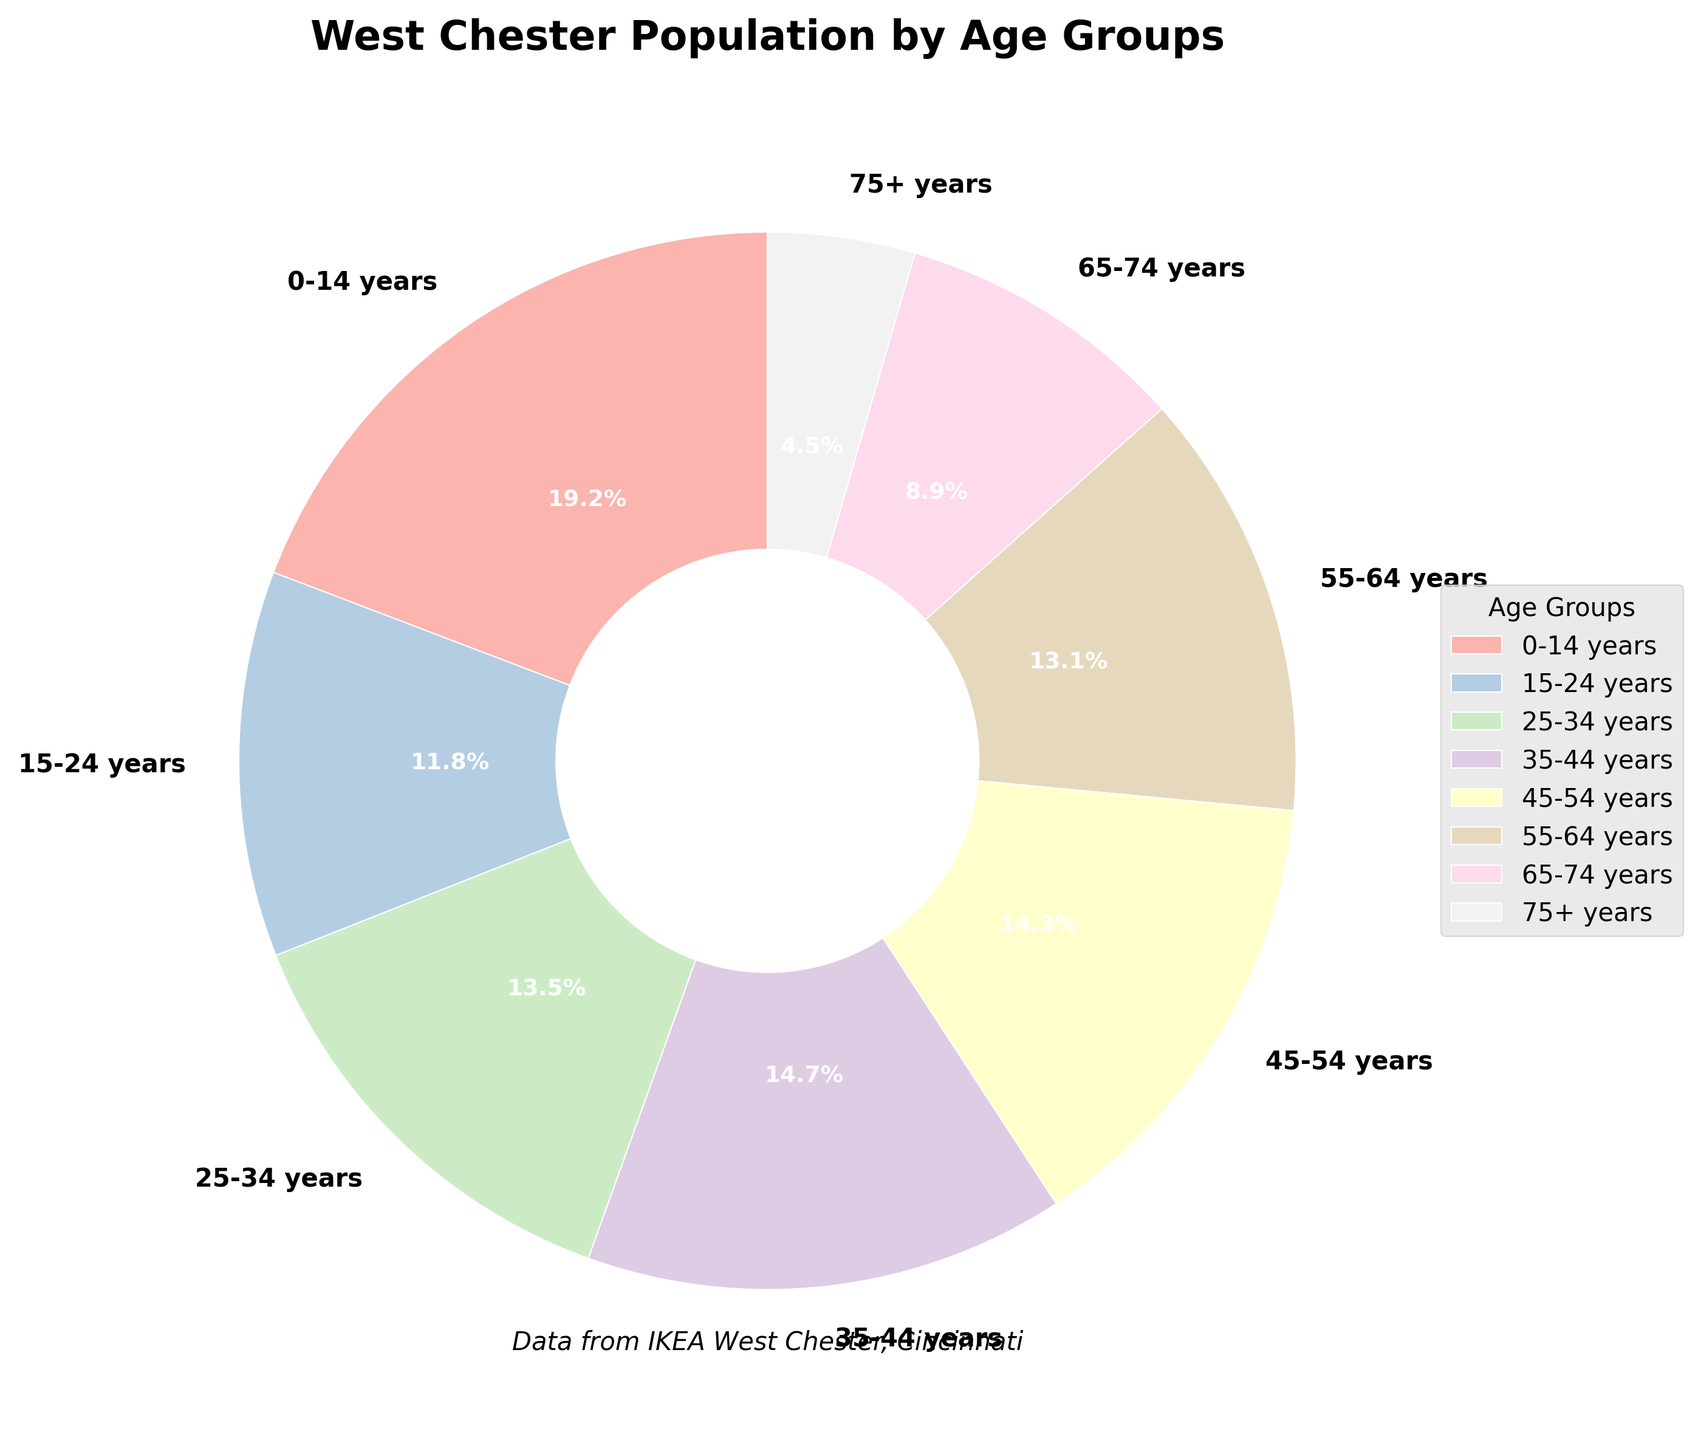Which age group has the highest percentage of the population? By visually inspecting the pie chart, the largest wedge represents the age group 0-14 years.
Answer: 0-14 years What is the total percentage of the population aged 35-54 years? Add the percentages of the 35-44 years (14.7%) and 45-54 years (14.3%) groups: 14.7% + 14.3% = 29.0%.
Answer: 29.0% Is the percentage of the population aged 25-34 years higher than that of those aged 55-64 years? If so, by how much? Compare the wedges for 25-34 years (13.5%) and 55-64 years (13.1%): 13.5% is higher than 13.1%. The difference is 13.5% - 13.1% = 0.4%.
Answer: Yes, by 0.4% What is the median percentage among all age groups? List the percentages in ascending order: 4.5%, 8.9%, 11.8%, 13.1%, 13.5%, 14.3%, 14.7%, 19.2%. The median is the average of the 4th and 5th values: (13.1% + 13.5%) / 2 = 13.3%.
Answer: 13.3% Which two age groups together make up more than a quarter of the total population? Add the percentages of age groups and check combinations: 0-14 years (19.2%) and 15-24 years (11.8%) together make 31.0%, which is more than 25%.
Answer: 0-14 years and 15-24 years Are there more people aged over 65 years or under 15 years? Compare the sum of percentages for those over 65 (75+ years 4.5% + 65-74 years 8.9% = 13.4%) with under 15 (0-14 years 19.2%). 19.2% > 13.4%.
Answer: Under 15 years What is the cumulative percentage of the population aged under 35 years? Add the percentages of the 0-14 years (19.2%), 15-24 years (11.8%), and 25-34 years (13.5%) groups: 19.2% + 11.8% + 13.5% = 44.5%.
Answer: 44.5% Which age group is represented by the smallest wedge on the pie chart? By visually inspecting the pie chart, the smallest wedge represents the age group 75+ years.
Answer: 75+ years 